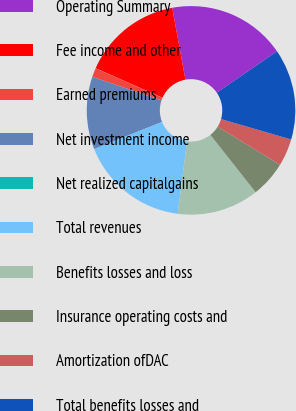Convert chart to OTSL. <chart><loc_0><loc_0><loc_500><loc_500><pie_chart><fcel>Operating Summary<fcel>Fee income and other<fcel>Earned premiums<fcel>Net investment income<fcel>Net realized capitalgains<fcel>Total revenues<fcel>Benefits losses and loss<fcel>Insurance operating costs and<fcel>Amortization ofDAC<fcel>Total benefits losses and<nl><fcel>18.31%<fcel>15.49%<fcel>1.41%<fcel>11.27%<fcel>0.0%<fcel>16.9%<fcel>12.68%<fcel>5.63%<fcel>4.23%<fcel>14.08%<nl></chart> 